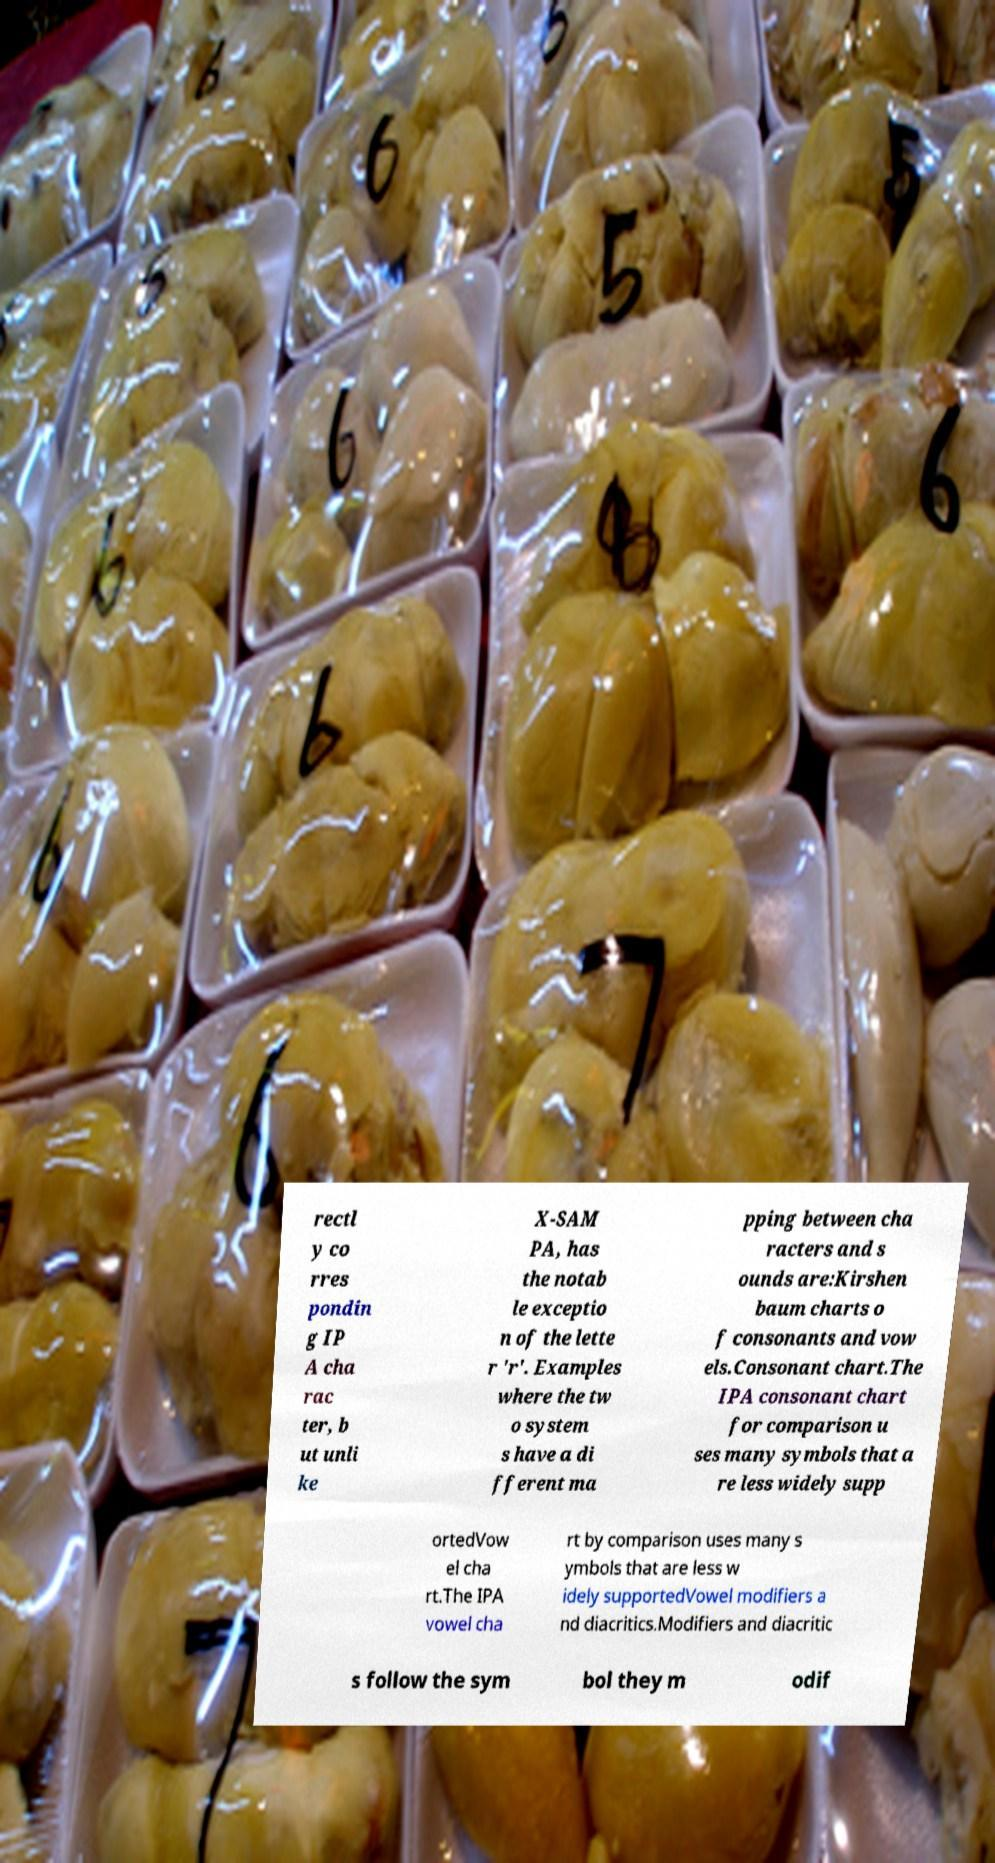Please identify and transcribe the text found in this image. rectl y co rres pondin g IP A cha rac ter, b ut unli ke X-SAM PA, has the notab le exceptio n of the lette r 'r'. Examples where the tw o system s have a di fferent ma pping between cha racters and s ounds are:Kirshen baum charts o f consonants and vow els.Consonant chart.The IPA consonant chart for comparison u ses many symbols that a re less widely supp ortedVow el cha rt.The IPA vowel cha rt by comparison uses many s ymbols that are less w idely supportedVowel modifiers a nd diacritics.Modifiers and diacritic s follow the sym bol they m odif 